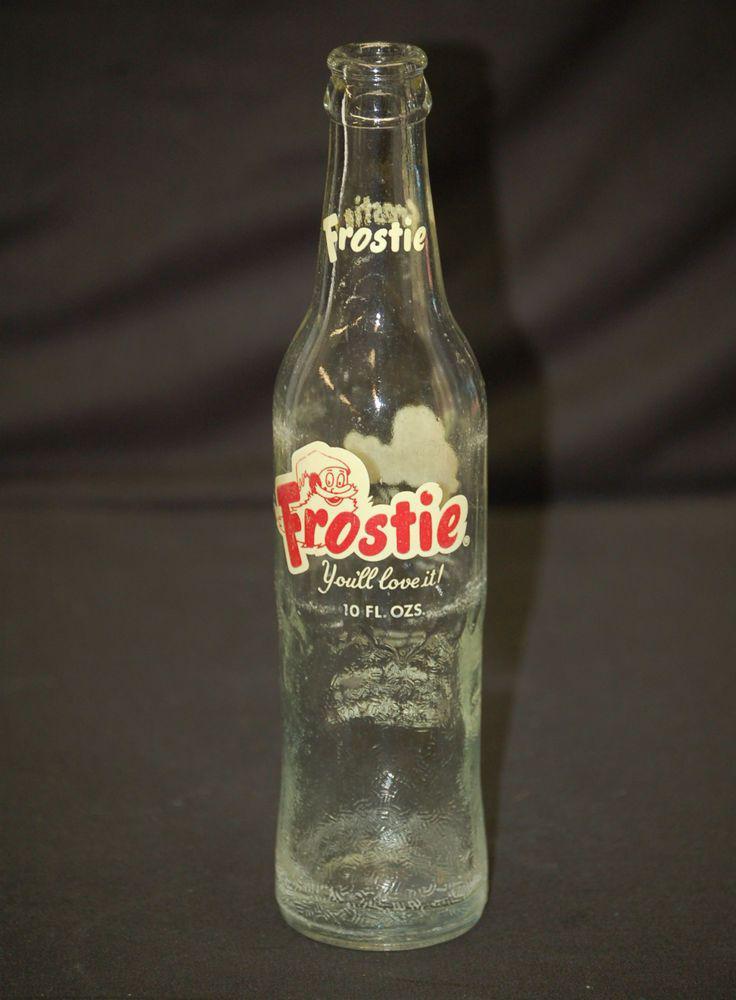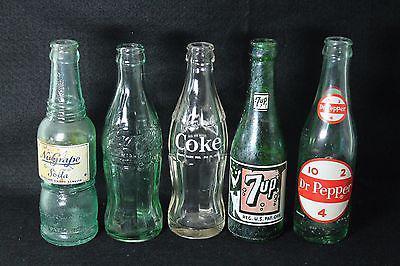The first image is the image on the left, the second image is the image on the right. Analyze the images presented: Is the assertion "At least 5 bottles are standing side by side in one of the pictures." valid? Answer yes or no. Yes. The first image is the image on the left, the second image is the image on the right. Assess this claim about the two images: "There are more than three bottles.". Correct or not? Answer yes or no. Yes. 